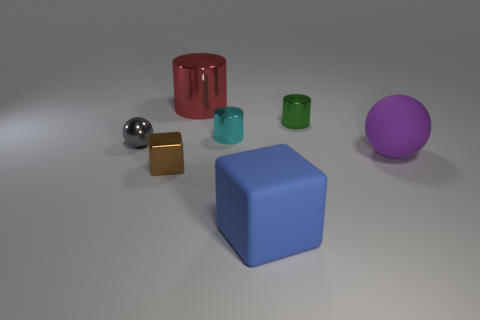Subtract all small green metal cylinders. How many cylinders are left? 2 Subtract all cylinders. How many objects are left? 4 Subtract 3 cylinders. How many cylinders are left? 0 Add 4 tiny gray spheres. How many tiny gray spheres are left? 5 Add 2 matte cubes. How many matte cubes exist? 3 Add 2 small red balls. How many objects exist? 9 Subtract all cyan cylinders. How many cylinders are left? 2 Subtract 0 blue cylinders. How many objects are left? 7 Subtract all brown blocks. Subtract all yellow balls. How many blocks are left? 1 Subtract all red balls. How many brown blocks are left? 1 